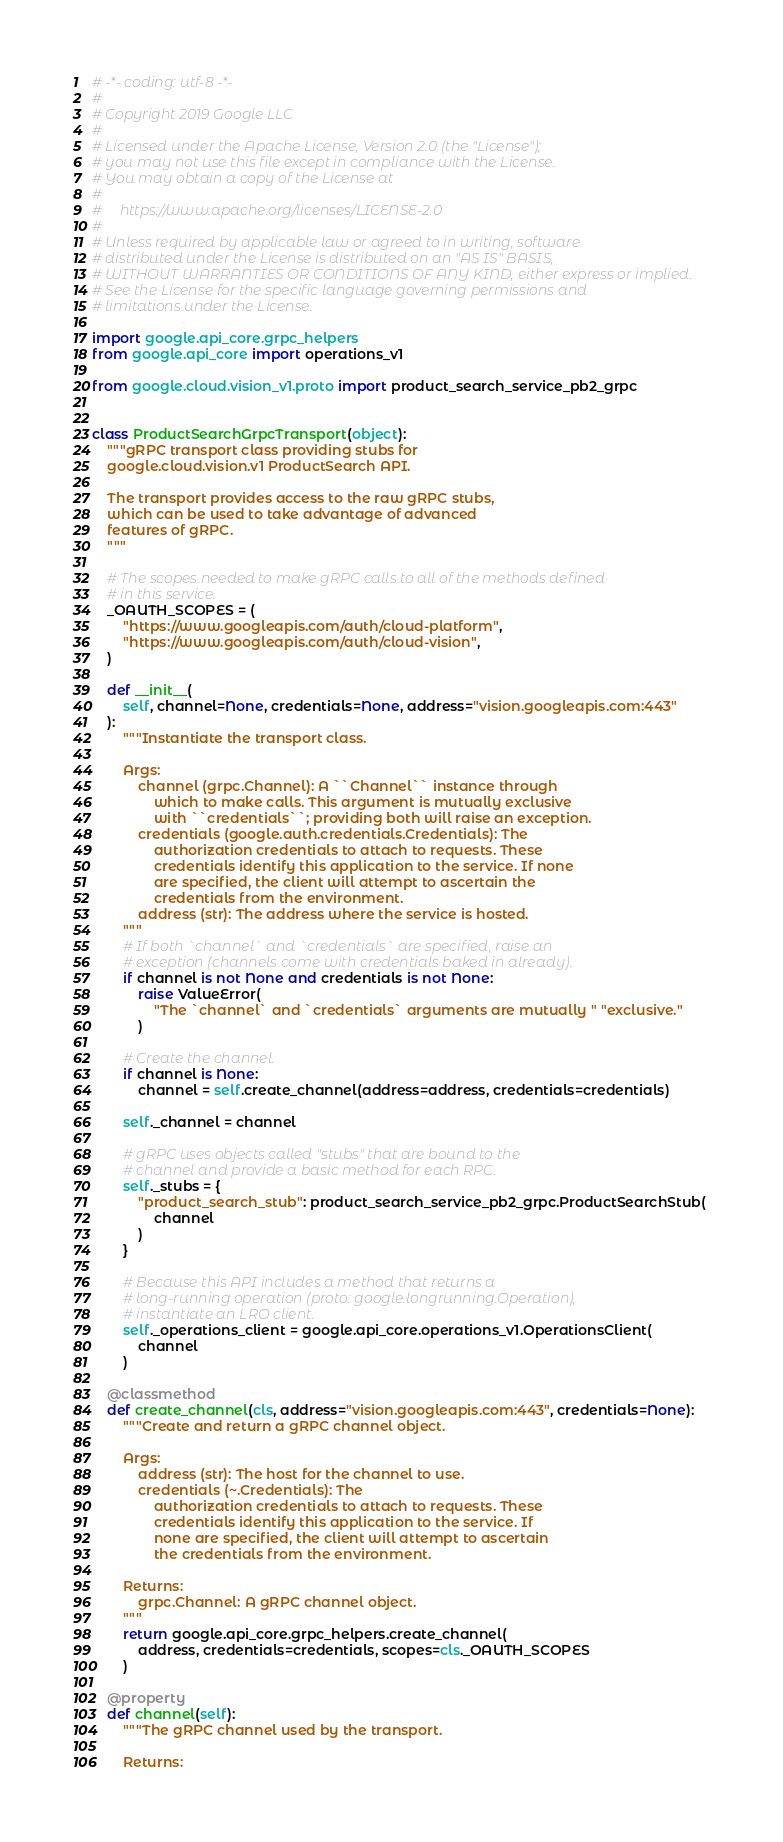<code> <loc_0><loc_0><loc_500><loc_500><_Python_># -*- coding: utf-8 -*-
#
# Copyright 2019 Google LLC
#
# Licensed under the Apache License, Version 2.0 (the "License");
# you may not use this file except in compliance with the License.
# You may obtain a copy of the License at
#
#     https://www.apache.org/licenses/LICENSE-2.0
#
# Unless required by applicable law or agreed to in writing, software
# distributed under the License is distributed on an "AS IS" BASIS,
# WITHOUT WARRANTIES OR CONDITIONS OF ANY KIND, either express or implied.
# See the License for the specific language governing permissions and
# limitations under the License.

import google.api_core.grpc_helpers
from google.api_core import operations_v1

from google.cloud.vision_v1.proto import product_search_service_pb2_grpc


class ProductSearchGrpcTransport(object):
    """gRPC transport class providing stubs for
    google.cloud.vision.v1 ProductSearch API.

    The transport provides access to the raw gRPC stubs,
    which can be used to take advantage of advanced
    features of gRPC.
    """

    # The scopes needed to make gRPC calls to all of the methods defined
    # in this service.
    _OAUTH_SCOPES = (
        "https://www.googleapis.com/auth/cloud-platform",
        "https://www.googleapis.com/auth/cloud-vision",
    )

    def __init__(
        self, channel=None, credentials=None, address="vision.googleapis.com:443"
    ):
        """Instantiate the transport class.

        Args:
            channel (grpc.Channel): A ``Channel`` instance through
                which to make calls. This argument is mutually exclusive
                with ``credentials``; providing both will raise an exception.
            credentials (google.auth.credentials.Credentials): The
                authorization credentials to attach to requests. These
                credentials identify this application to the service. If none
                are specified, the client will attempt to ascertain the
                credentials from the environment.
            address (str): The address where the service is hosted.
        """
        # If both `channel` and `credentials` are specified, raise an
        # exception (channels come with credentials baked in already).
        if channel is not None and credentials is not None:
            raise ValueError(
                "The `channel` and `credentials` arguments are mutually " "exclusive."
            )

        # Create the channel.
        if channel is None:
            channel = self.create_channel(address=address, credentials=credentials)

        self._channel = channel

        # gRPC uses objects called "stubs" that are bound to the
        # channel and provide a basic method for each RPC.
        self._stubs = {
            "product_search_stub": product_search_service_pb2_grpc.ProductSearchStub(
                channel
            )
        }

        # Because this API includes a method that returns a
        # long-running operation (proto: google.longrunning.Operation),
        # instantiate an LRO client.
        self._operations_client = google.api_core.operations_v1.OperationsClient(
            channel
        )

    @classmethod
    def create_channel(cls, address="vision.googleapis.com:443", credentials=None):
        """Create and return a gRPC channel object.

        Args:
            address (str): The host for the channel to use.
            credentials (~.Credentials): The
                authorization credentials to attach to requests. These
                credentials identify this application to the service. If
                none are specified, the client will attempt to ascertain
                the credentials from the environment.

        Returns:
            grpc.Channel: A gRPC channel object.
        """
        return google.api_core.grpc_helpers.create_channel(
            address, credentials=credentials, scopes=cls._OAUTH_SCOPES
        )

    @property
    def channel(self):
        """The gRPC channel used by the transport.

        Returns:</code> 